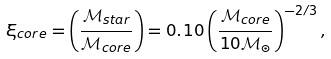Convert formula to latex. <formula><loc_0><loc_0><loc_500><loc_500>\xi _ { c o r e } = \left ( \frac { \mathcal { M } _ { s t a r } } { \mathcal { M } _ { c o r e } } \right ) = 0 . 1 0 \left ( \frac { \mathcal { M } _ { c o r e } } { 1 0 \mathcal { M } _ { \odot } } \right ) ^ { - 2 / 3 } ,</formula> 